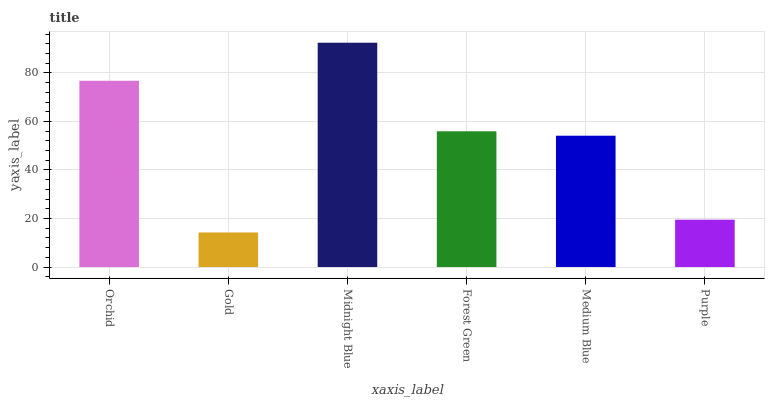Is Gold the minimum?
Answer yes or no. Yes. Is Midnight Blue the maximum?
Answer yes or no. Yes. Is Midnight Blue the minimum?
Answer yes or no. No. Is Gold the maximum?
Answer yes or no. No. Is Midnight Blue greater than Gold?
Answer yes or no. Yes. Is Gold less than Midnight Blue?
Answer yes or no. Yes. Is Gold greater than Midnight Blue?
Answer yes or no. No. Is Midnight Blue less than Gold?
Answer yes or no. No. Is Forest Green the high median?
Answer yes or no. Yes. Is Medium Blue the low median?
Answer yes or no. Yes. Is Midnight Blue the high median?
Answer yes or no. No. Is Midnight Blue the low median?
Answer yes or no. No. 